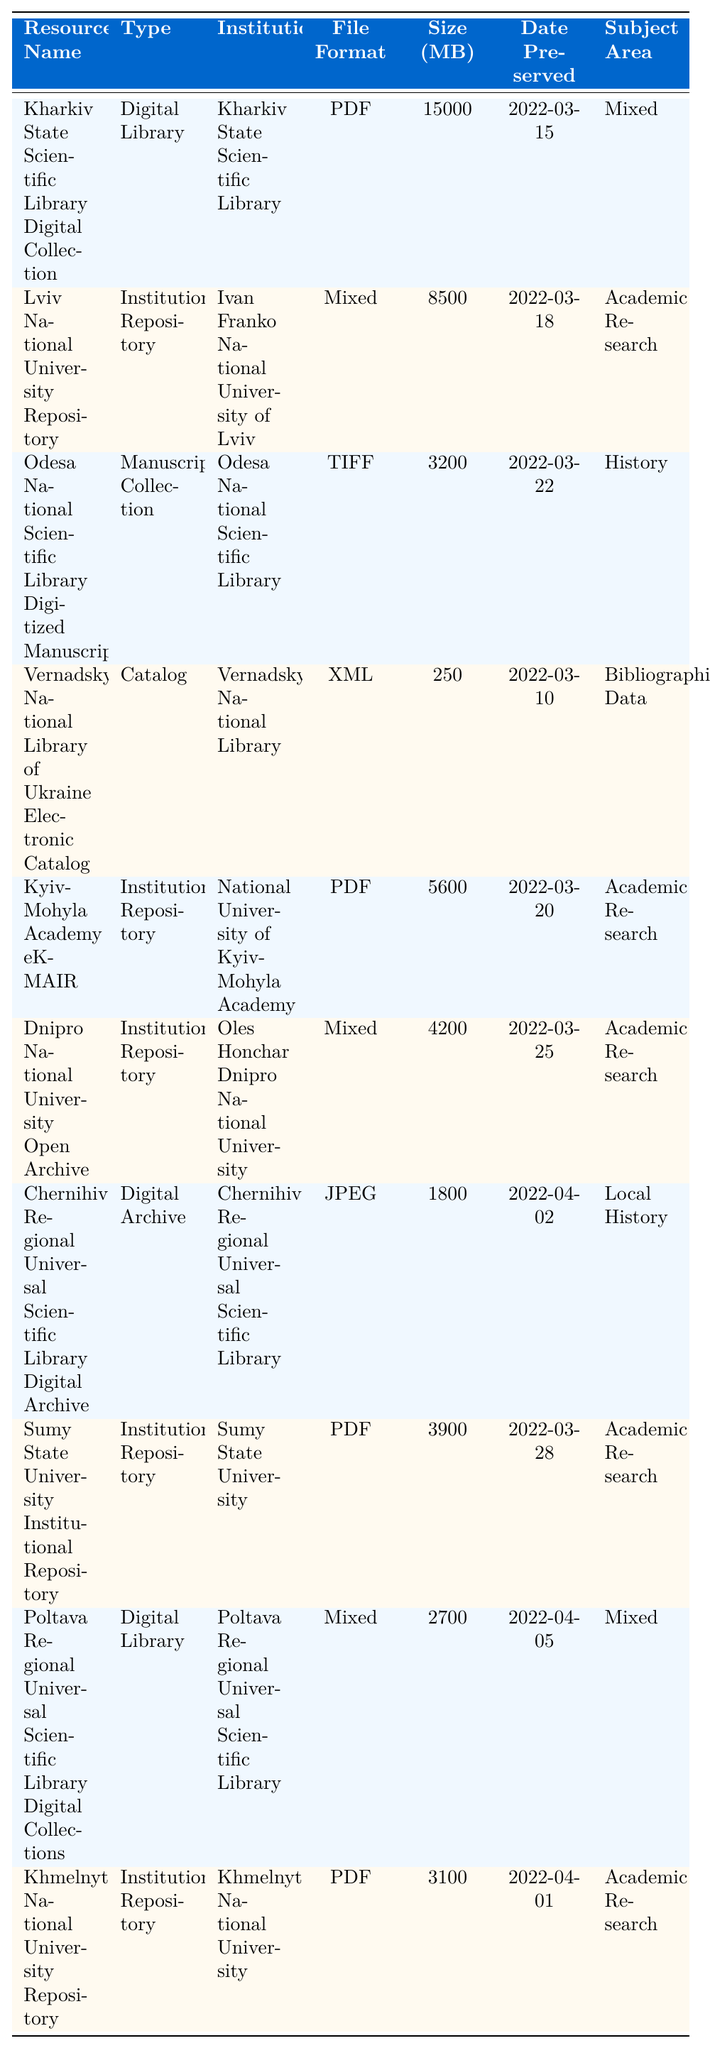What is the file format of the "Dnipro National University Open Archive"? Looking at the row for "Dnipro National University Open Archive," the file format listed is "Mixed."
Answer: Mixed Which resource has the largest size in MB? The "Kharkiv State Scientific Library Digital Collection" is 15000 MB, which is the largest size in the table.
Answer: 15000 MB How many resources are categorized under "Institutional Repository"? The table lists 5 resources under "Institutional Repository": Lviv National University Repository, Kyiv-Mohyla Academy eKMAIR, Dnipro National University Open Archive, Sumy State University Institutional Repository, and Khmelnytskyi National University Repository.
Answer: 5 What is the subject area of the "Odesa National Scientific Library Digitized Manuscripts"? The subject area listed for the "Odesa National Scientific Library Digitized Manuscripts" is "History."
Answer: History Calculate the average size of all digital libraries in MB. The sizes of the digital libraries are 15000 (Kharkiv) and 2700 (Poltava), summing to 17700. There are 2 digital libraries, so the average size is 17700 / 2 = 8850 MB.
Answer: 8850 MB Is the "Vernadsky National Library of Ukraine Electronic Catalog" larger than 500 MB? The size of the "Vernadsky National Library of Ukraine Electronic Catalog" is 250 MB, which is not larger than 500 MB.
Answer: No Which institution has the most resources in the table? There are 5 different institutions in the table, but "Academic Research" appears as the subject area for 4 resources, likely indicating a variety of submissions from this focus area, though not a single institution dominates.
Answer: No single institution dominates On what date was the "Chernihiv Regional Universal Scientific Library Digital Archive" preserved? The date preserved for "Chernihiv Regional Universal Scientific Library Digital Archive" is listed as "2022-04-02."
Answer: 2022-04-02 How many resources have been preserved in PDF format? The resources in PDF format are Kharkiv State Scientific Library Digital Collection, Kyiv-Mohyla Academy eKMAIR, Sumy State University Institutional Repository, and Khmelnytskyi National University Repository, totaling 4 resources in PDF format.
Answer: 4 What is the smallest file size among the resources? The smallest file size in the table is the "Vernadsky National Library of Ukraine Electronic Catalog," which is 250 MB.
Answer: 250 MB 